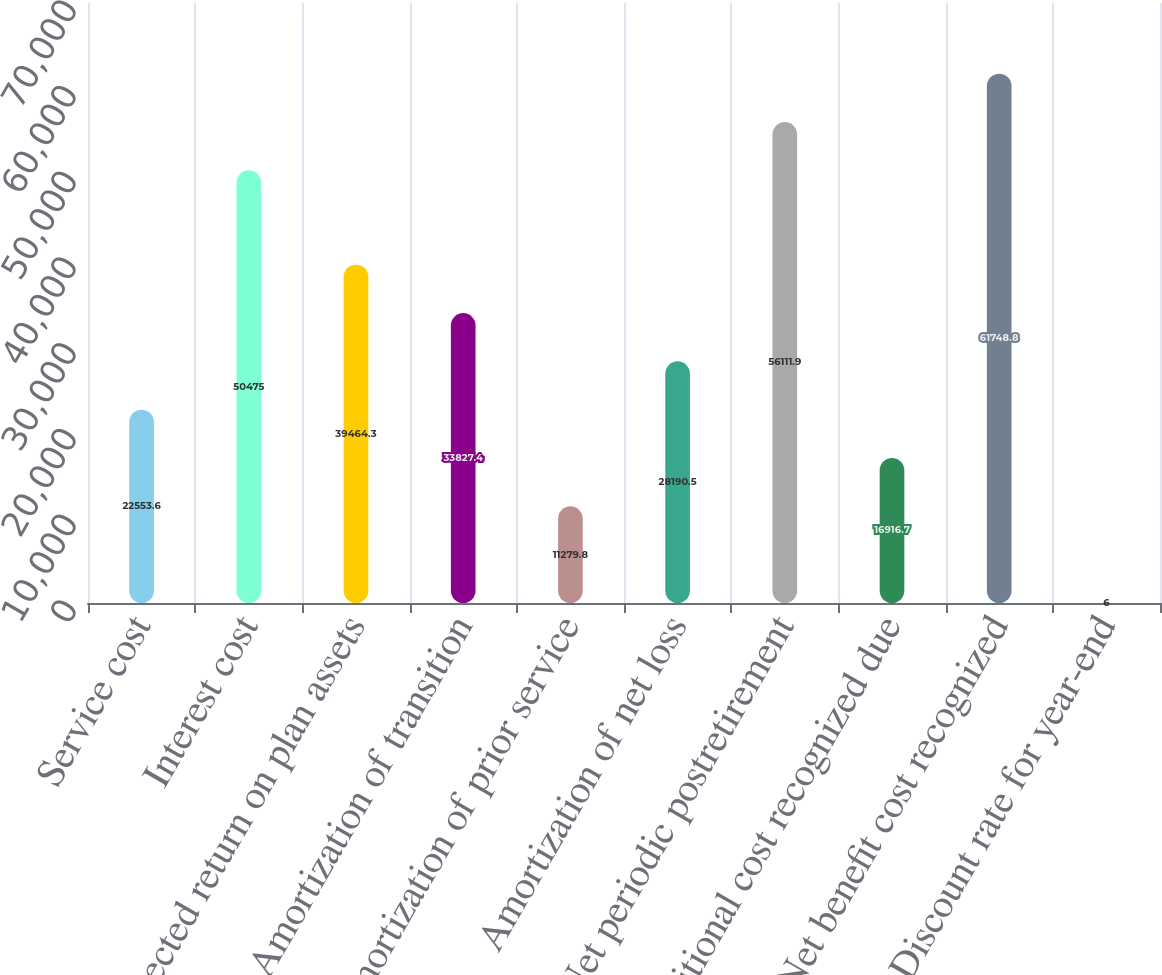<chart> <loc_0><loc_0><loc_500><loc_500><bar_chart><fcel>Service cost<fcel>Interest cost<fcel>Expected return on plan assets<fcel>Amortization of transition<fcel>Amortization of prior service<fcel>Amortization of net loss<fcel>Net periodic postretirement<fcel>Additional cost recognized due<fcel>Net benefit cost recognized<fcel>Discount rate for year-end<nl><fcel>22553.6<fcel>50475<fcel>39464.3<fcel>33827.4<fcel>11279.8<fcel>28190.5<fcel>56111.9<fcel>16916.7<fcel>61748.8<fcel>6<nl></chart> 